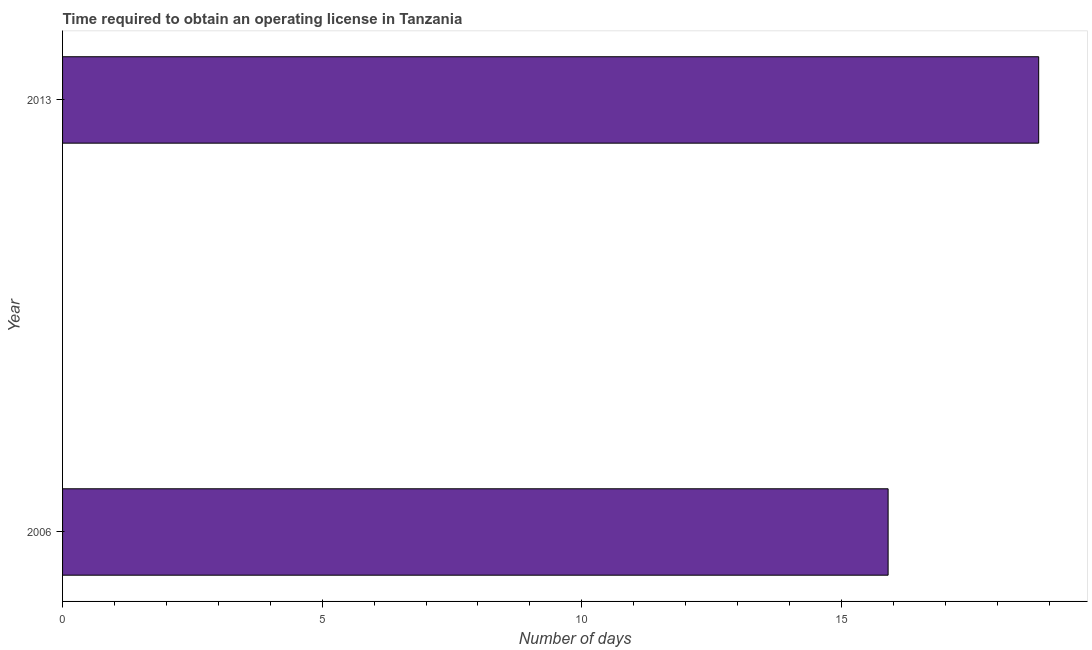Does the graph contain any zero values?
Give a very brief answer. No. What is the title of the graph?
Ensure brevity in your answer.  Time required to obtain an operating license in Tanzania. What is the label or title of the X-axis?
Keep it short and to the point. Number of days. Across all years, what is the maximum number of days to obtain operating license?
Keep it short and to the point. 18.8. In which year was the number of days to obtain operating license maximum?
Ensure brevity in your answer.  2013. In which year was the number of days to obtain operating license minimum?
Your response must be concise. 2006. What is the sum of the number of days to obtain operating license?
Offer a very short reply. 34.7. What is the average number of days to obtain operating license per year?
Provide a succinct answer. 17.35. What is the median number of days to obtain operating license?
Ensure brevity in your answer.  17.35. In how many years, is the number of days to obtain operating license greater than 9 days?
Keep it short and to the point. 2. Do a majority of the years between 2006 and 2013 (inclusive) have number of days to obtain operating license greater than 16 days?
Provide a succinct answer. No. What is the ratio of the number of days to obtain operating license in 2006 to that in 2013?
Give a very brief answer. 0.85. How many bars are there?
Give a very brief answer. 2. Are the values on the major ticks of X-axis written in scientific E-notation?
Provide a short and direct response. No. What is the Number of days of 2006?
Make the answer very short. 15.9. What is the ratio of the Number of days in 2006 to that in 2013?
Offer a very short reply. 0.85. 